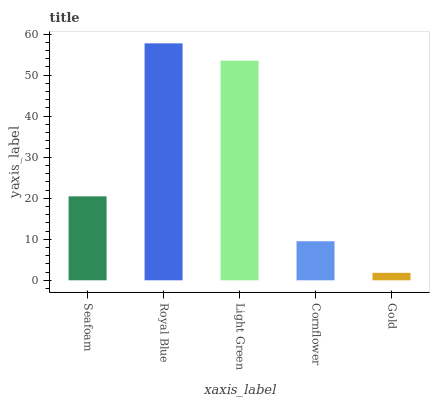Is Gold the minimum?
Answer yes or no. Yes. Is Royal Blue the maximum?
Answer yes or no. Yes. Is Light Green the minimum?
Answer yes or no. No. Is Light Green the maximum?
Answer yes or no. No. Is Royal Blue greater than Light Green?
Answer yes or no. Yes. Is Light Green less than Royal Blue?
Answer yes or no. Yes. Is Light Green greater than Royal Blue?
Answer yes or no. No. Is Royal Blue less than Light Green?
Answer yes or no. No. Is Seafoam the high median?
Answer yes or no. Yes. Is Seafoam the low median?
Answer yes or no. Yes. Is Gold the high median?
Answer yes or no. No. Is Cornflower the low median?
Answer yes or no. No. 